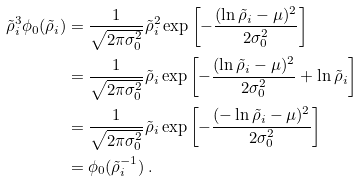<formula> <loc_0><loc_0><loc_500><loc_500>\tilde { \rho } _ { i } ^ { 3 } \phi _ { 0 } ( \tilde { \rho } _ { i } ) & = \frac { 1 } { \sqrt { 2 \pi \sigma _ { 0 } ^ { 2 } } } \tilde { \rho } _ { i } ^ { 2 } \exp \left [ - \frac { ( \ln \tilde { \rho } _ { i } - \mu ) ^ { 2 } } { 2 \sigma _ { 0 } ^ { 2 } } \right ] \\ & = \frac { 1 } { \sqrt { 2 \pi \sigma _ { 0 } ^ { 2 } } } \tilde { \rho } _ { i } \exp \left [ - \frac { ( \ln \tilde { \rho } _ { i } - \mu ) ^ { 2 } } { 2 \sigma _ { 0 } ^ { 2 } } + \ln \tilde { \rho } _ { i } \right ] \\ & = \frac { 1 } { \sqrt { 2 \pi \sigma _ { 0 } ^ { 2 } } } \tilde { \rho } _ { i } \exp \left [ - \frac { ( - \ln \tilde { \rho } _ { i } - \mu ) ^ { 2 } } { 2 \sigma _ { 0 } ^ { 2 } } \right ] \\ & = \phi _ { 0 } ( \tilde { \rho } _ { i } ^ { - 1 } ) \, .</formula> 